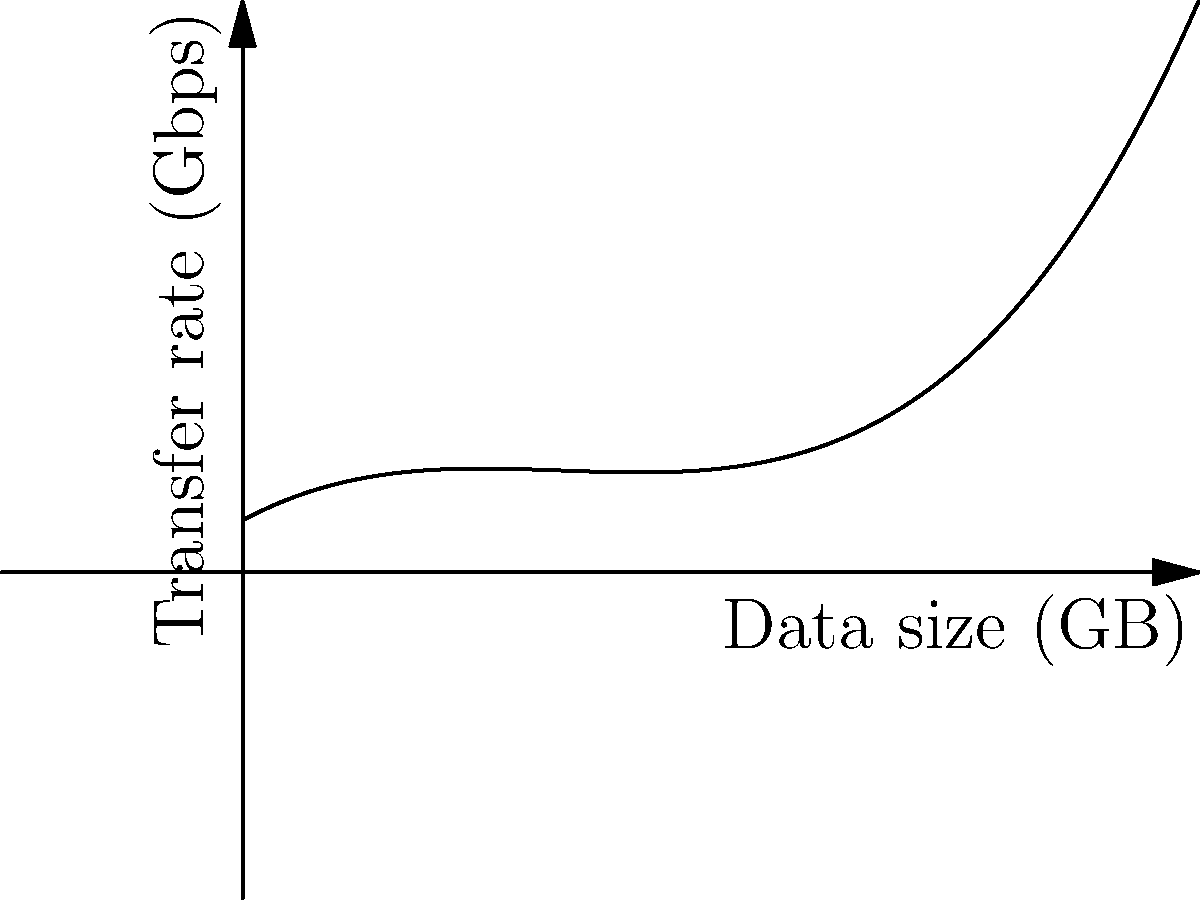The graph represents a polynomial approximation of data transfer rates based on data size. If the transfer rate $f(x)$ in Gbps is given by $f(x) = 0.5x^3 - 2x^2 + 2.5x + 1$, where $x$ is the data size in GB, calculate the average rate of change in transfer speed between points A (1 GB, 2 Gbps) and B (3 GB, 5.5 Gbps). To find the average rate of change between two points, we use the slope formula:

1. Identify the coordinates of points A and B:
   A: (1, 2)
   B: (3, 5.5)

2. Apply the slope formula:
   $\text{Average rate of change} = \frac{y_2 - y_1}{x_2 - x_1}$

3. Substitute the values:
   $\text{Average rate of change} = \frac{5.5 - 2}{3 - 1}$

4. Simplify:
   $\text{Average rate of change} = \frac{3.5}{2}$

5. Calculate the final result:
   $\text{Average rate of change} = 1.75$

Therefore, the average rate of change in transfer speed between points A and B is 1.75 Gbps/GB.
Answer: 1.75 Gbps/GB 